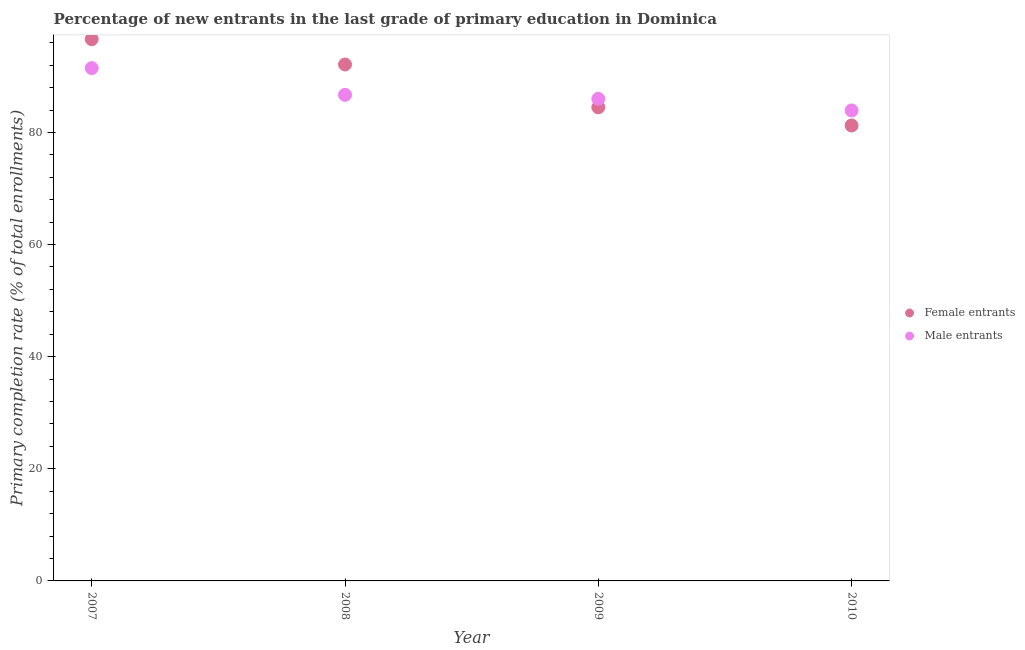Is the number of dotlines equal to the number of legend labels?
Offer a terse response. Yes. What is the primary completion rate of male entrants in 2007?
Your answer should be very brief. 91.47. Across all years, what is the maximum primary completion rate of male entrants?
Your answer should be compact. 91.47. Across all years, what is the minimum primary completion rate of male entrants?
Ensure brevity in your answer.  83.92. What is the total primary completion rate of female entrants in the graph?
Keep it short and to the point. 354.48. What is the difference between the primary completion rate of female entrants in 2008 and that in 2010?
Your response must be concise. 10.88. What is the difference between the primary completion rate of male entrants in 2009 and the primary completion rate of female entrants in 2008?
Your response must be concise. -6.12. What is the average primary completion rate of male entrants per year?
Keep it short and to the point. 87.02. In the year 2007, what is the difference between the primary completion rate of female entrants and primary completion rate of male entrants?
Your response must be concise. 5.16. In how many years, is the primary completion rate of male entrants greater than 8 %?
Make the answer very short. 4. What is the ratio of the primary completion rate of male entrants in 2007 to that in 2008?
Offer a terse response. 1.05. Is the difference between the primary completion rate of male entrants in 2007 and 2009 greater than the difference between the primary completion rate of female entrants in 2007 and 2009?
Provide a short and direct response. No. What is the difference between the highest and the second highest primary completion rate of female entrants?
Your answer should be compact. 4.51. What is the difference between the highest and the lowest primary completion rate of male entrants?
Offer a very short reply. 7.55. In how many years, is the primary completion rate of male entrants greater than the average primary completion rate of male entrants taken over all years?
Offer a terse response. 1. Is the sum of the primary completion rate of male entrants in 2008 and 2010 greater than the maximum primary completion rate of female entrants across all years?
Ensure brevity in your answer.  Yes. How many dotlines are there?
Give a very brief answer. 2. What is the difference between two consecutive major ticks on the Y-axis?
Your answer should be very brief. 20. Does the graph contain any zero values?
Give a very brief answer. No. Does the graph contain grids?
Offer a terse response. No. How many legend labels are there?
Give a very brief answer. 2. What is the title of the graph?
Keep it short and to the point. Percentage of new entrants in the last grade of primary education in Dominica. Does "Males" appear as one of the legend labels in the graph?
Make the answer very short. No. What is the label or title of the Y-axis?
Offer a very short reply. Primary completion rate (% of total enrollments). What is the Primary completion rate (% of total enrollments) in Female entrants in 2007?
Give a very brief answer. 96.63. What is the Primary completion rate (% of total enrollments) in Male entrants in 2007?
Offer a very short reply. 91.47. What is the Primary completion rate (% of total enrollments) in Female entrants in 2008?
Keep it short and to the point. 92.12. What is the Primary completion rate (% of total enrollments) of Male entrants in 2008?
Give a very brief answer. 86.71. What is the Primary completion rate (% of total enrollments) of Female entrants in 2009?
Give a very brief answer. 84.48. What is the Primary completion rate (% of total enrollments) of Male entrants in 2009?
Your answer should be compact. 86. What is the Primary completion rate (% of total enrollments) of Female entrants in 2010?
Make the answer very short. 81.24. What is the Primary completion rate (% of total enrollments) in Male entrants in 2010?
Your response must be concise. 83.92. Across all years, what is the maximum Primary completion rate (% of total enrollments) in Female entrants?
Your response must be concise. 96.63. Across all years, what is the maximum Primary completion rate (% of total enrollments) in Male entrants?
Offer a terse response. 91.47. Across all years, what is the minimum Primary completion rate (% of total enrollments) of Female entrants?
Your answer should be very brief. 81.24. Across all years, what is the minimum Primary completion rate (% of total enrollments) in Male entrants?
Give a very brief answer. 83.92. What is the total Primary completion rate (% of total enrollments) in Female entrants in the graph?
Provide a succinct answer. 354.48. What is the total Primary completion rate (% of total enrollments) in Male entrants in the graph?
Give a very brief answer. 348.1. What is the difference between the Primary completion rate (% of total enrollments) of Female entrants in 2007 and that in 2008?
Offer a very short reply. 4.51. What is the difference between the Primary completion rate (% of total enrollments) in Male entrants in 2007 and that in 2008?
Your answer should be compact. 4.77. What is the difference between the Primary completion rate (% of total enrollments) of Female entrants in 2007 and that in 2009?
Your answer should be compact. 12.15. What is the difference between the Primary completion rate (% of total enrollments) in Male entrants in 2007 and that in 2009?
Offer a terse response. 5.47. What is the difference between the Primary completion rate (% of total enrollments) in Female entrants in 2007 and that in 2010?
Offer a terse response. 15.39. What is the difference between the Primary completion rate (% of total enrollments) of Male entrants in 2007 and that in 2010?
Offer a terse response. 7.55. What is the difference between the Primary completion rate (% of total enrollments) of Female entrants in 2008 and that in 2009?
Make the answer very short. 7.64. What is the difference between the Primary completion rate (% of total enrollments) of Male entrants in 2008 and that in 2009?
Your answer should be very brief. 0.71. What is the difference between the Primary completion rate (% of total enrollments) of Female entrants in 2008 and that in 2010?
Keep it short and to the point. 10.88. What is the difference between the Primary completion rate (% of total enrollments) of Male entrants in 2008 and that in 2010?
Your answer should be very brief. 2.78. What is the difference between the Primary completion rate (% of total enrollments) in Female entrants in 2009 and that in 2010?
Offer a terse response. 3.24. What is the difference between the Primary completion rate (% of total enrollments) in Male entrants in 2009 and that in 2010?
Ensure brevity in your answer.  2.07. What is the difference between the Primary completion rate (% of total enrollments) of Female entrants in 2007 and the Primary completion rate (% of total enrollments) of Male entrants in 2008?
Provide a succinct answer. 9.93. What is the difference between the Primary completion rate (% of total enrollments) in Female entrants in 2007 and the Primary completion rate (% of total enrollments) in Male entrants in 2009?
Offer a terse response. 10.64. What is the difference between the Primary completion rate (% of total enrollments) in Female entrants in 2007 and the Primary completion rate (% of total enrollments) in Male entrants in 2010?
Your answer should be compact. 12.71. What is the difference between the Primary completion rate (% of total enrollments) of Female entrants in 2008 and the Primary completion rate (% of total enrollments) of Male entrants in 2009?
Offer a very short reply. 6.12. What is the difference between the Primary completion rate (% of total enrollments) in Female entrants in 2008 and the Primary completion rate (% of total enrollments) in Male entrants in 2010?
Your answer should be compact. 8.2. What is the difference between the Primary completion rate (% of total enrollments) in Female entrants in 2009 and the Primary completion rate (% of total enrollments) in Male entrants in 2010?
Ensure brevity in your answer.  0.56. What is the average Primary completion rate (% of total enrollments) in Female entrants per year?
Your answer should be very brief. 88.62. What is the average Primary completion rate (% of total enrollments) in Male entrants per year?
Keep it short and to the point. 87.02. In the year 2007, what is the difference between the Primary completion rate (% of total enrollments) in Female entrants and Primary completion rate (% of total enrollments) in Male entrants?
Your response must be concise. 5.16. In the year 2008, what is the difference between the Primary completion rate (% of total enrollments) of Female entrants and Primary completion rate (% of total enrollments) of Male entrants?
Your answer should be compact. 5.42. In the year 2009, what is the difference between the Primary completion rate (% of total enrollments) of Female entrants and Primary completion rate (% of total enrollments) of Male entrants?
Keep it short and to the point. -1.51. In the year 2010, what is the difference between the Primary completion rate (% of total enrollments) of Female entrants and Primary completion rate (% of total enrollments) of Male entrants?
Provide a short and direct response. -2.68. What is the ratio of the Primary completion rate (% of total enrollments) of Female entrants in 2007 to that in 2008?
Make the answer very short. 1.05. What is the ratio of the Primary completion rate (% of total enrollments) of Male entrants in 2007 to that in 2008?
Your answer should be compact. 1.05. What is the ratio of the Primary completion rate (% of total enrollments) in Female entrants in 2007 to that in 2009?
Keep it short and to the point. 1.14. What is the ratio of the Primary completion rate (% of total enrollments) in Male entrants in 2007 to that in 2009?
Give a very brief answer. 1.06. What is the ratio of the Primary completion rate (% of total enrollments) of Female entrants in 2007 to that in 2010?
Give a very brief answer. 1.19. What is the ratio of the Primary completion rate (% of total enrollments) in Male entrants in 2007 to that in 2010?
Provide a short and direct response. 1.09. What is the ratio of the Primary completion rate (% of total enrollments) of Female entrants in 2008 to that in 2009?
Provide a succinct answer. 1.09. What is the ratio of the Primary completion rate (% of total enrollments) in Male entrants in 2008 to that in 2009?
Your answer should be compact. 1.01. What is the ratio of the Primary completion rate (% of total enrollments) of Female entrants in 2008 to that in 2010?
Ensure brevity in your answer.  1.13. What is the ratio of the Primary completion rate (% of total enrollments) in Male entrants in 2008 to that in 2010?
Make the answer very short. 1.03. What is the ratio of the Primary completion rate (% of total enrollments) in Female entrants in 2009 to that in 2010?
Offer a very short reply. 1.04. What is the ratio of the Primary completion rate (% of total enrollments) of Male entrants in 2009 to that in 2010?
Your answer should be very brief. 1.02. What is the difference between the highest and the second highest Primary completion rate (% of total enrollments) in Female entrants?
Provide a succinct answer. 4.51. What is the difference between the highest and the second highest Primary completion rate (% of total enrollments) in Male entrants?
Your response must be concise. 4.77. What is the difference between the highest and the lowest Primary completion rate (% of total enrollments) of Female entrants?
Your answer should be compact. 15.39. What is the difference between the highest and the lowest Primary completion rate (% of total enrollments) in Male entrants?
Your answer should be very brief. 7.55. 